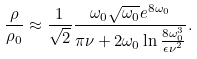<formula> <loc_0><loc_0><loc_500><loc_500>\frac { \rho } { \rho _ { 0 } } \approx \frac { 1 } { \sqrt { 2 } } \frac { \omega _ { 0 } \sqrt { \omega _ { 0 } } e ^ { 8 \omega _ { 0 } } } { \pi \nu + 2 \omega _ { 0 } \ln { \frac { 8 \omega _ { 0 } ^ { 3 } } { \epsilon \nu ^ { 2 } } } } .</formula> 